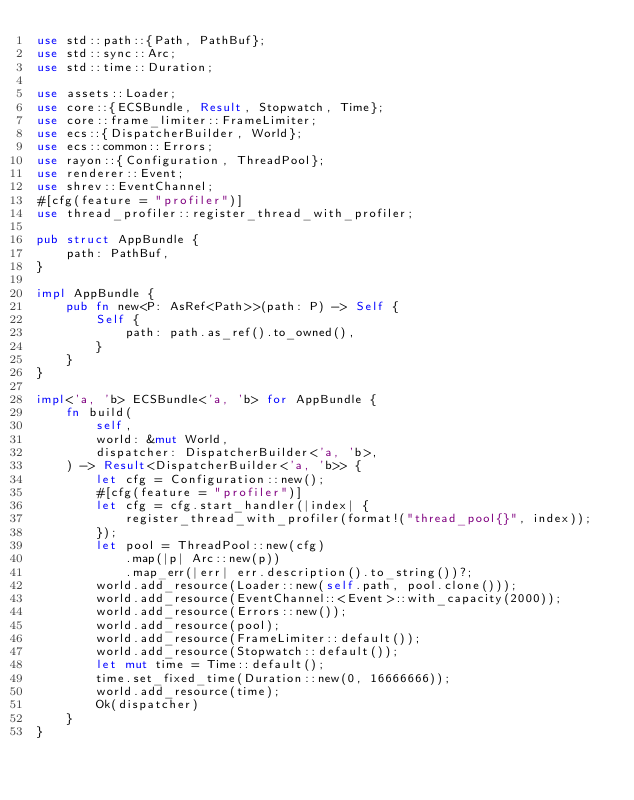Convert code to text. <code><loc_0><loc_0><loc_500><loc_500><_Rust_>use std::path::{Path, PathBuf};
use std::sync::Arc;
use std::time::Duration;

use assets::Loader;
use core::{ECSBundle, Result, Stopwatch, Time};
use core::frame_limiter::FrameLimiter;
use ecs::{DispatcherBuilder, World};
use ecs::common::Errors;
use rayon::{Configuration, ThreadPool};
use renderer::Event;
use shrev::EventChannel;
#[cfg(feature = "profiler")]
use thread_profiler::register_thread_with_profiler;

pub struct AppBundle {
    path: PathBuf,
}

impl AppBundle {
    pub fn new<P: AsRef<Path>>(path: P) -> Self {
        Self {
            path: path.as_ref().to_owned(),
        }
    }
}

impl<'a, 'b> ECSBundle<'a, 'b> for AppBundle {
    fn build(
        self,
        world: &mut World,
        dispatcher: DispatcherBuilder<'a, 'b>,
    ) -> Result<DispatcherBuilder<'a, 'b>> {
        let cfg = Configuration::new();
        #[cfg(feature = "profiler")]
        let cfg = cfg.start_handler(|index| {
            register_thread_with_profiler(format!("thread_pool{}", index));
        });
        let pool = ThreadPool::new(cfg)
            .map(|p| Arc::new(p))
            .map_err(|err| err.description().to_string())?;
        world.add_resource(Loader::new(self.path, pool.clone()));
        world.add_resource(EventChannel::<Event>::with_capacity(2000));
        world.add_resource(Errors::new());
        world.add_resource(pool);
        world.add_resource(FrameLimiter::default());
        world.add_resource(Stopwatch::default());
        let mut time = Time::default();
        time.set_fixed_time(Duration::new(0, 16666666));
        world.add_resource(time);
        Ok(dispatcher)
    }
}
</code> 